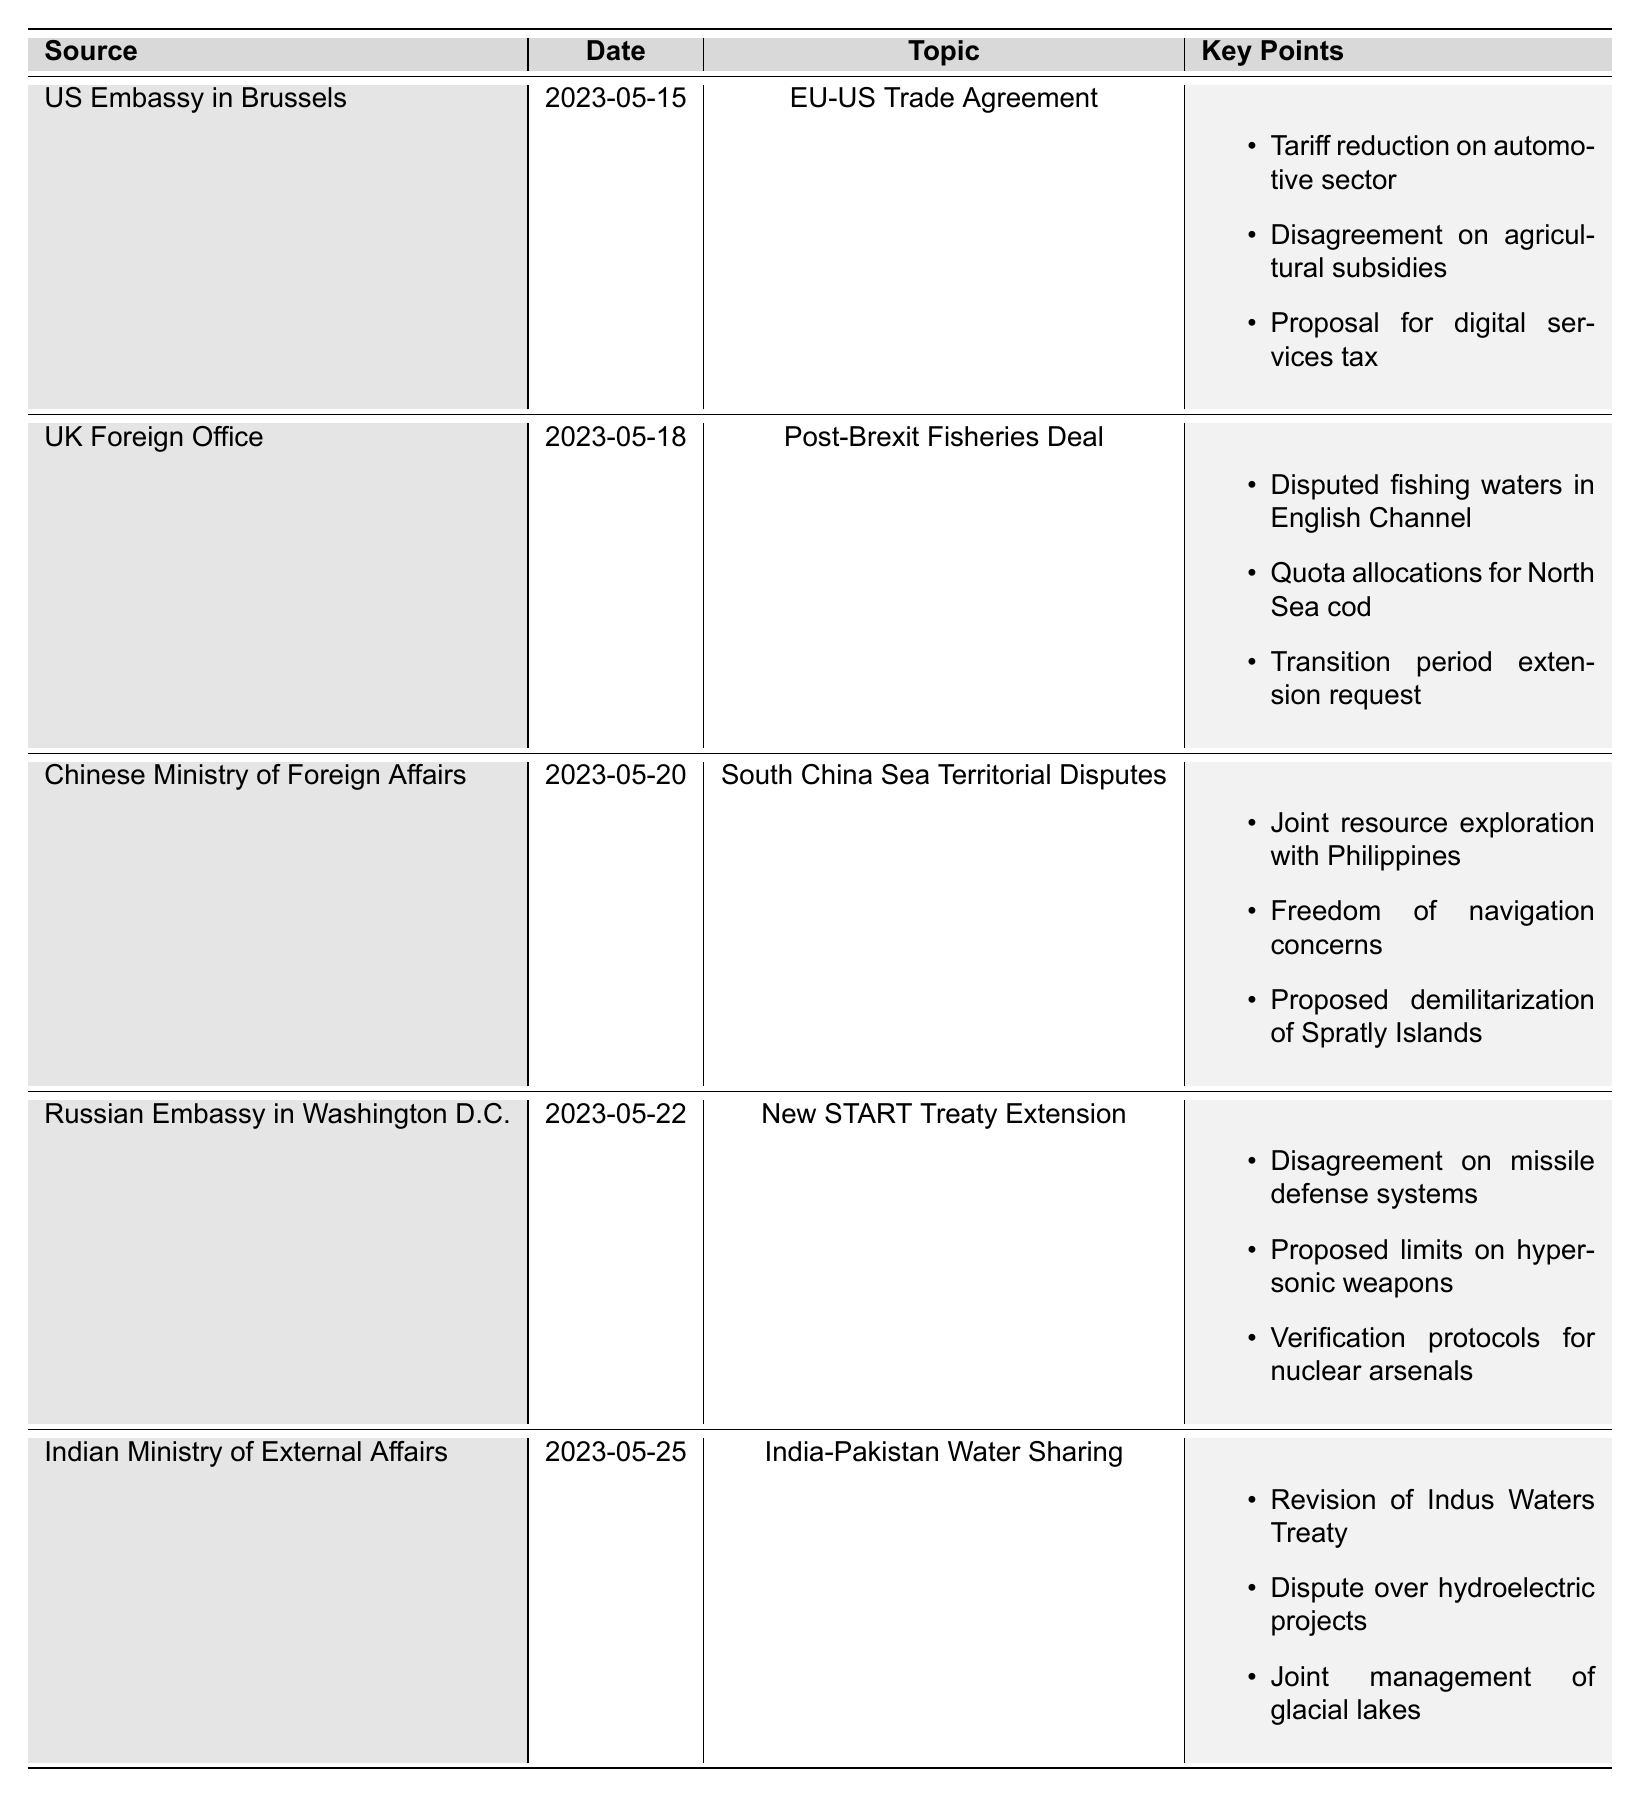What is the topic of the cable from the US Embassy in Brussels? The table lists the source, date, topic, and key points for each diplomatic cable. Looking at the entry for the US Embassy in Brussels, the topic is specified as "EU-US Trade Agreement."
Answer: EU-US Trade Agreement Which country is involved in the Post-Brexit Fisheries Deal? The relevant row in the table shows the source as the UK Foreign Office, indicating that the country involved in this deal is the United Kingdom.
Answer: United Kingdom How many key points are listed for the South China Sea Territorial Disputes? By examining the entry for the South China Sea Territorial Disputes in the table, I see there are three key points listed: joint resource exploration, freedom of navigation concerns, and proposed demilitarization.
Answer: 3 Did the Russian Embassy address issues regarding hypersonic weapons in the cable? The table indicates under the key points for the New START Treaty Extension that there is a proposed limit on hypersonic weapons, thus confirming this issue was addressed in the cable.
Answer: Yes What are the key points mentioned in the cable from the Indian Ministry of External Affairs? The table shows that for the India-Pakistan Water Sharing topic, the key points include: revision of the Indus Waters Treaty, dispute over hydroelectric projects, and joint management of glacial lakes.
Answer: Revision of Indus Waters Treaty, dispute over hydroelectric projects, joint management of glacial lakes Which diplomatic cable has the earliest date, and what is its topic? The dates listed in the table make it clear that the cable from the US Embassy in Brussels on 2023-05-15 is the earliest, with the topic being the EU-US Trade Agreement.
Answer: EU-US Trade Agreement Is there a disagreement mentioned regarding agricultural subsidies in the EU-US Trade Agreement negotiations? The table notes a key point for the EU-US Trade Agreement that explicitly states there is a disagreement on agricultural subsidies, indicating it is indeed mentioned.
Answer: Yes Compare the number of key points between the cables from the UK Foreign Office and the Russian Embassy; which has more? The UK Foreign Office has three key points in the Post-Brexit Fisheries Deal, whereas the Russian Embassy has three key points as well for the New START Treaty Extension. Comparing them indicates they are equal in number of key points.
Answer: Equal What are the similar themes found in the key points of cables from China and Russia? The cable from China mentions joint resource exploration and freedom of navigation, while the cable from Russia concerns verification protocols and missile defense; both discussions involve security and governance in regional contexts. Thus, a common theme is international security and resource management.
Answer: International security and resource management Which source has a cable dated after May 20, 2023? The table lists three cables with dates after May 20, 2023: the Russian Embassy in Washington D.C. (2023-05-22), and the Indian Ministry of External Affairs (2023-05-25). Reviewing these dates confirms this information.
Answer: Russian Embassy in Washington D.C., Indian Ministry of External Affairs 